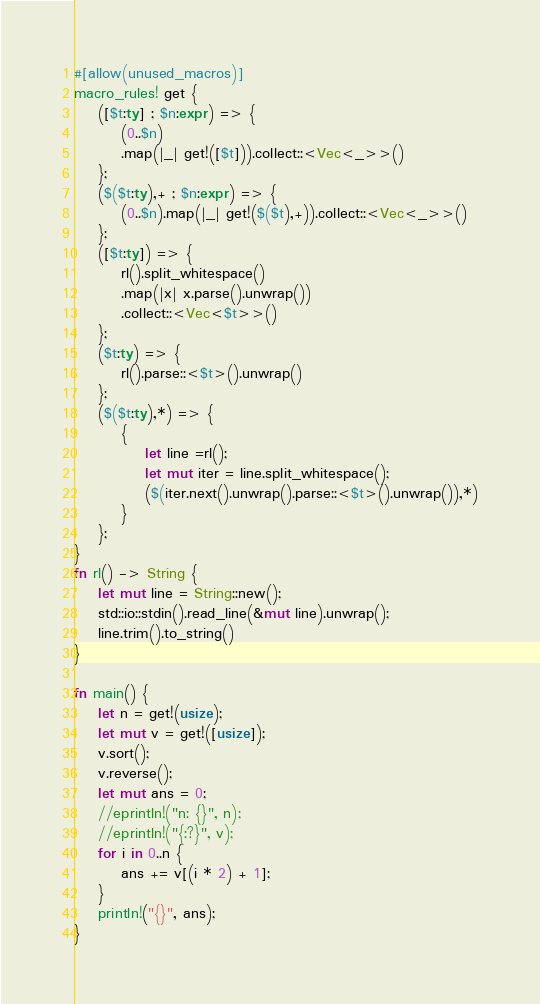Convert code to text. <code><loc_0><loc_0><loc_500><loc_500><_Rust_>#[allow(unused_macros)]
macro_rules! get {
    ([$t:ty] ; $n:expr) => {
        (0..$n)
        .map(|_| get!([$t])).collect::<Vec<_>>()
    };
    ($($t:ty),+ ; $n:expr) => {
        (0..$n).map(|_| get!($($t),+)).collect::<Vec<_>>()
    };
    ([$t:ty]) => {
        rl().split_whitespace()
        .map(|x| x.parse().unwrap())
        .collect::<Vec<$t>>()
    };
    ($t:ty) => {
        rl().parse::<$t>().unwrap()
    };
    ($($t:ty),*) => {
        {
            let line =rl();
            let mut iter = line.split_whitespace();
            ($(iter.next().unwrap().parse::<$t>().unwrap()),*)
        }
    };
}
fn rl() -> String {
    let mut line = String::new();
    std::io::stdin().read_line(&mut line).unwrap();
    line.trim().to_string()
}

fn main() {
    let n = get!(usize);
    let mut v = get!([usize]);
    v.sort();
    v.reverse();
    let mut ans = 0;
    //eprintln!("n: {}", n);
    //eprintln!("{:?}", v);
    for i in 0..n {
        ans += v[(i * 2) + 1];
    }
    println!("{}", ans);
}
</code> 